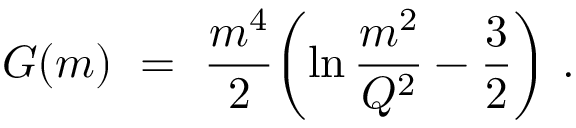Convert formula to latex. <formula><loc_0><loc_0><loc_500><loc_500>G ( m ) \ = \ { \frac { m ^ { 4 } } { 2 } } \left ( \ln { \frac { m ^ { 2 } } { Q ^ { 2 } } } - { \frac { 3 } { 2 } } \right ) \ .</formula> 